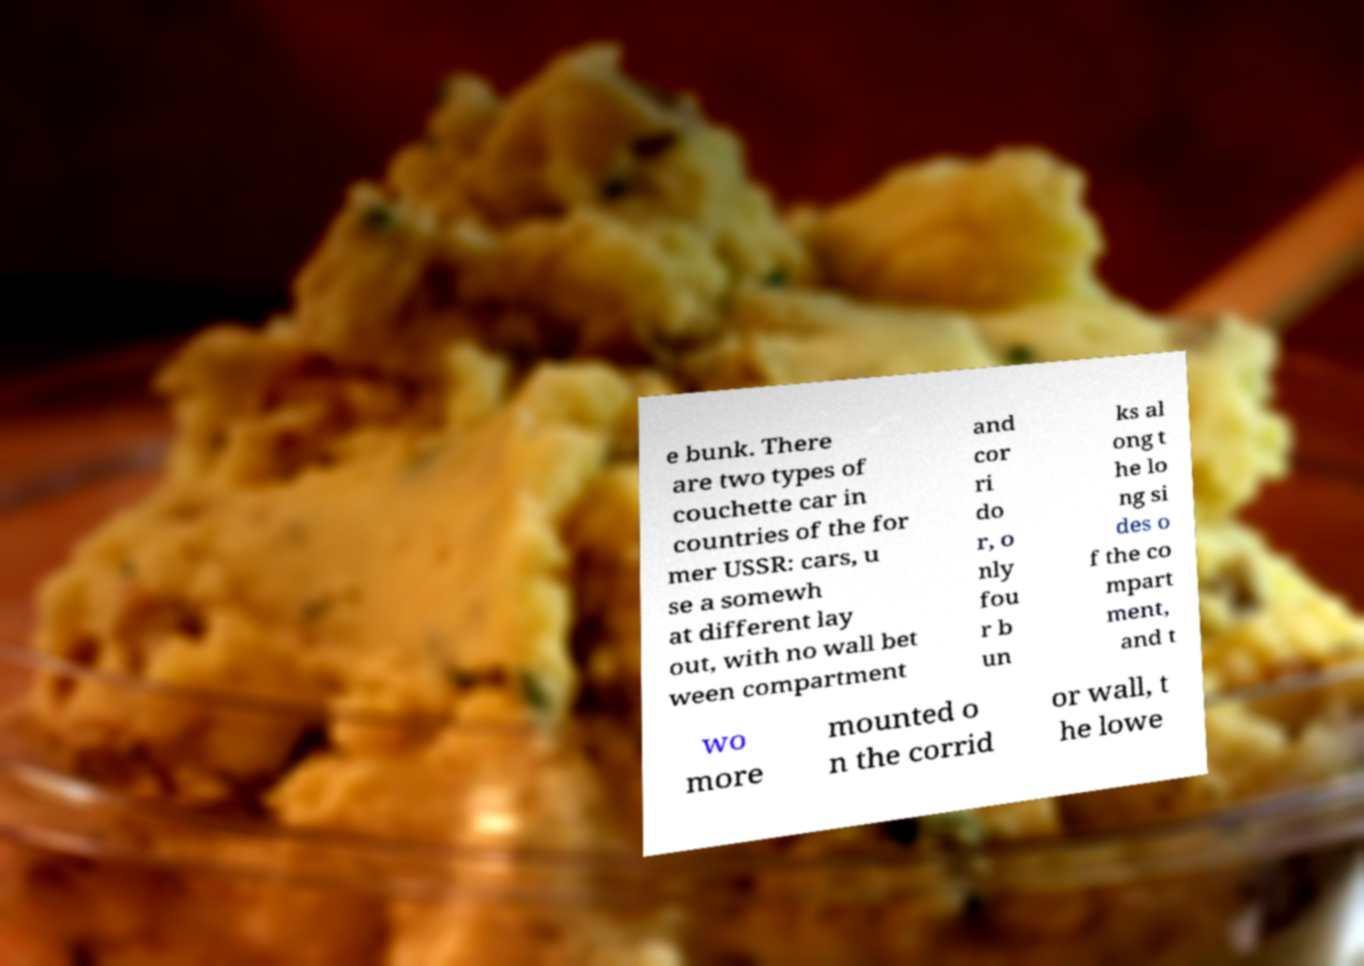For documentation purposes, I need the text within this image transcribed. Could you provide that? e bunk. There are two types of couchette car in countries of the for mer USSR: cars, u se a somewh at different lay out, with no wall bet ween compartment and cor ri do r, o nly fou r b un ks al ong t he lo ng si des o f the co mpart ment, and t wo more mounted o n the corrid or wall, t he lowe 